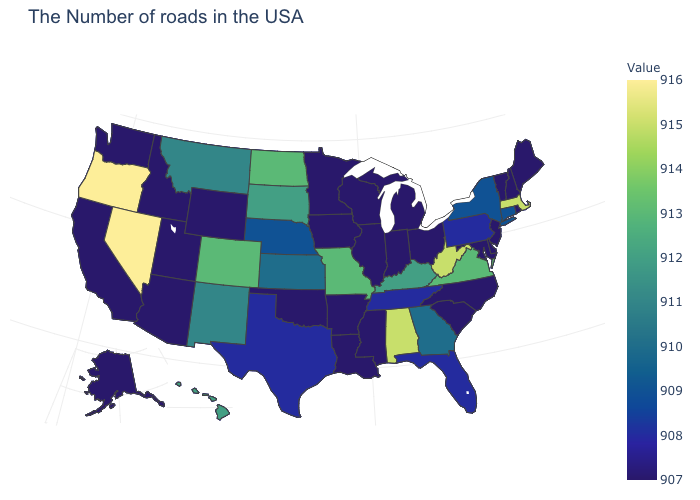Is the legend a continuous bar?
Short answer required. Yes. 